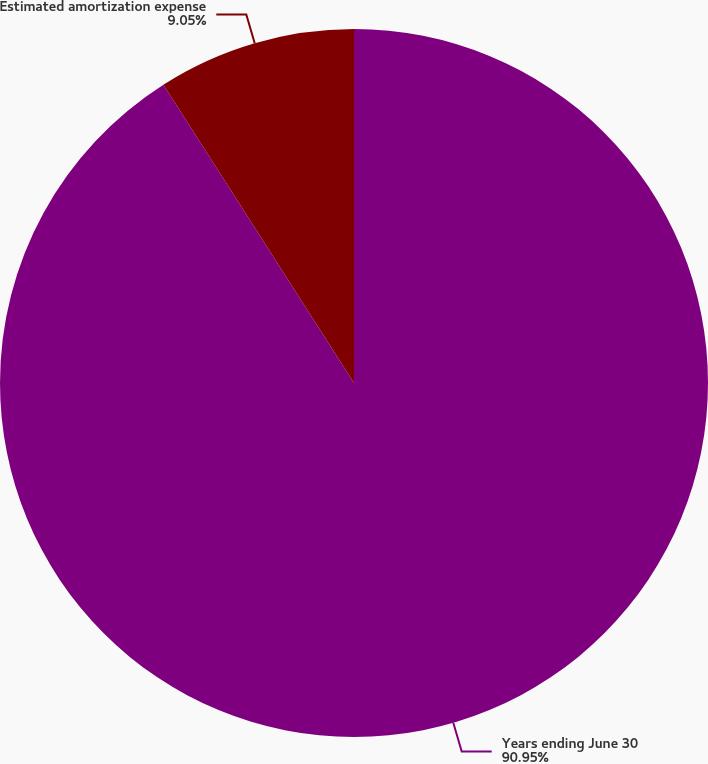<chart> <loc_0><loc_0><loc_500><loc_500><pie_chart><fcel>Years ending June 30<fcel>Estimated amortization expense<nl><fcel>90.95%<fcel>9.05%<nl></chart> 